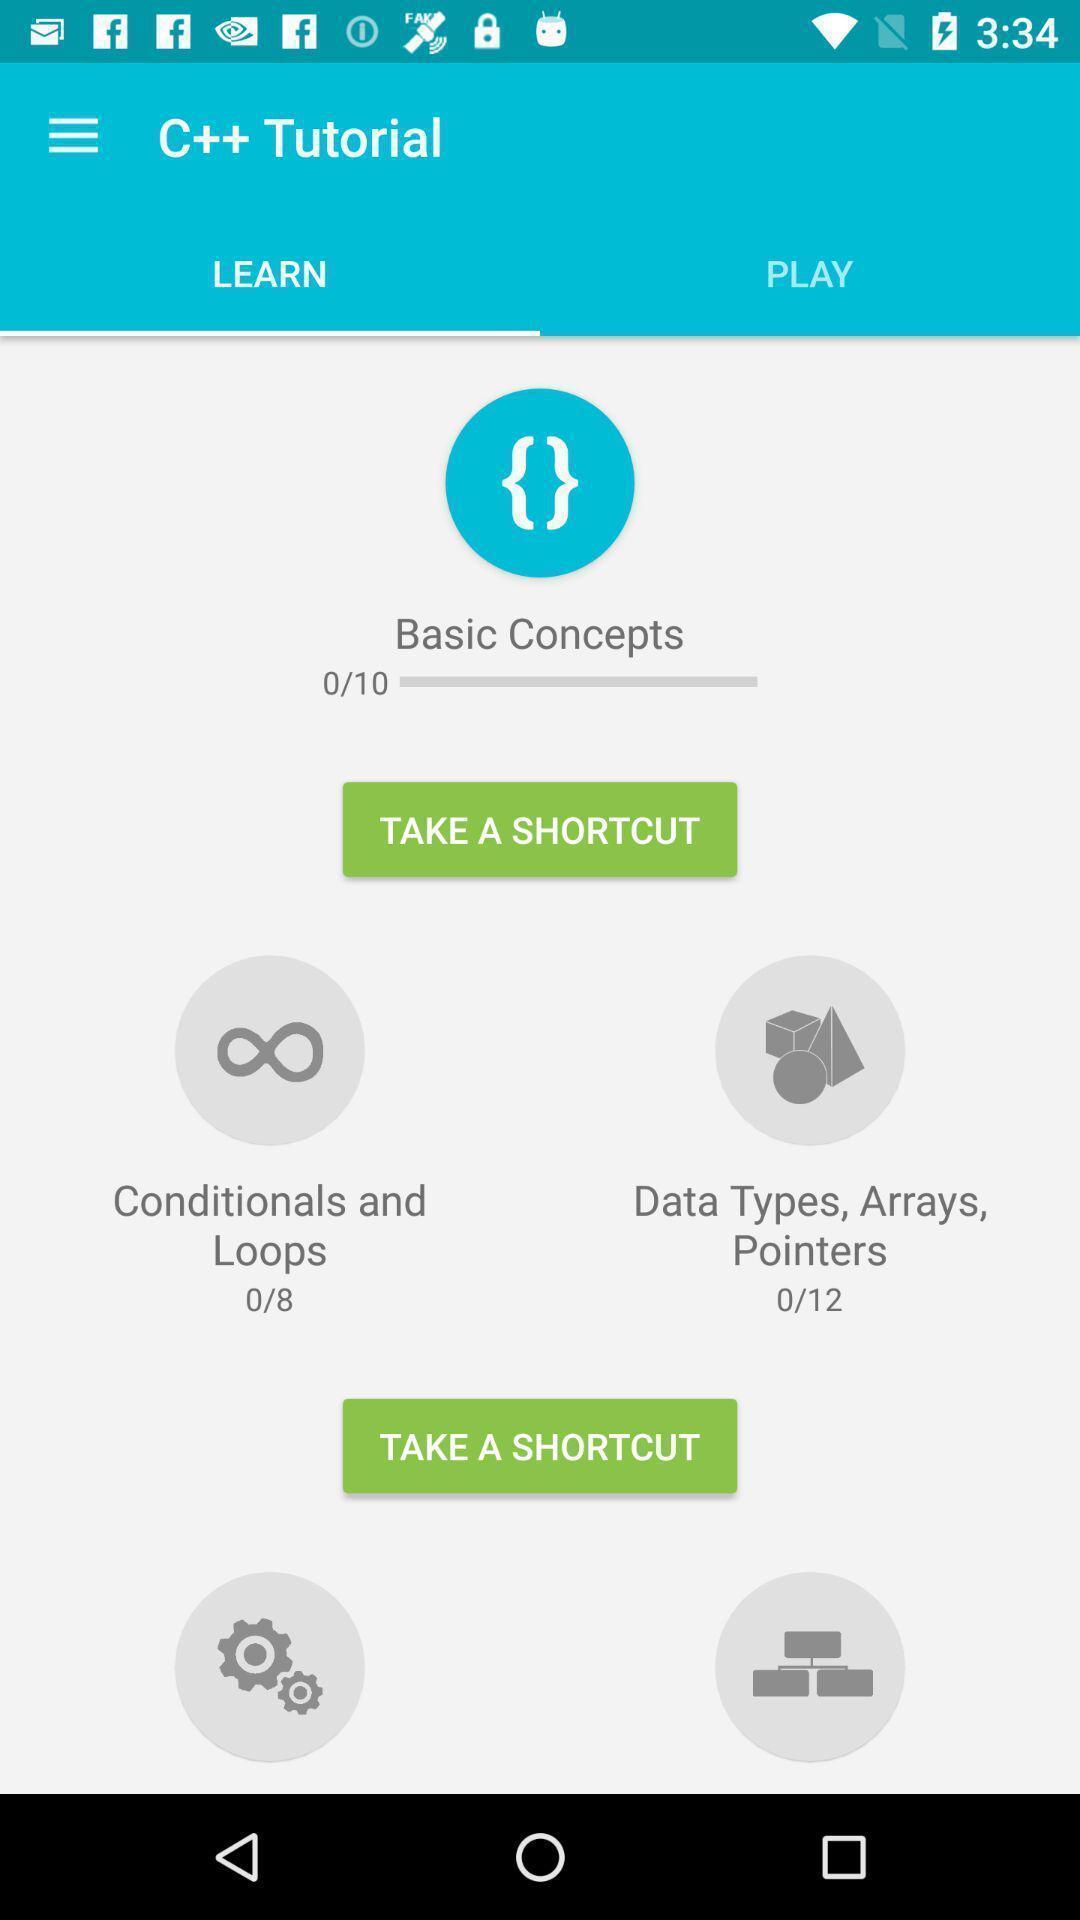Tell me about the visual elements in this screen capture. Page displaying to take shortcuts in a learning app. 